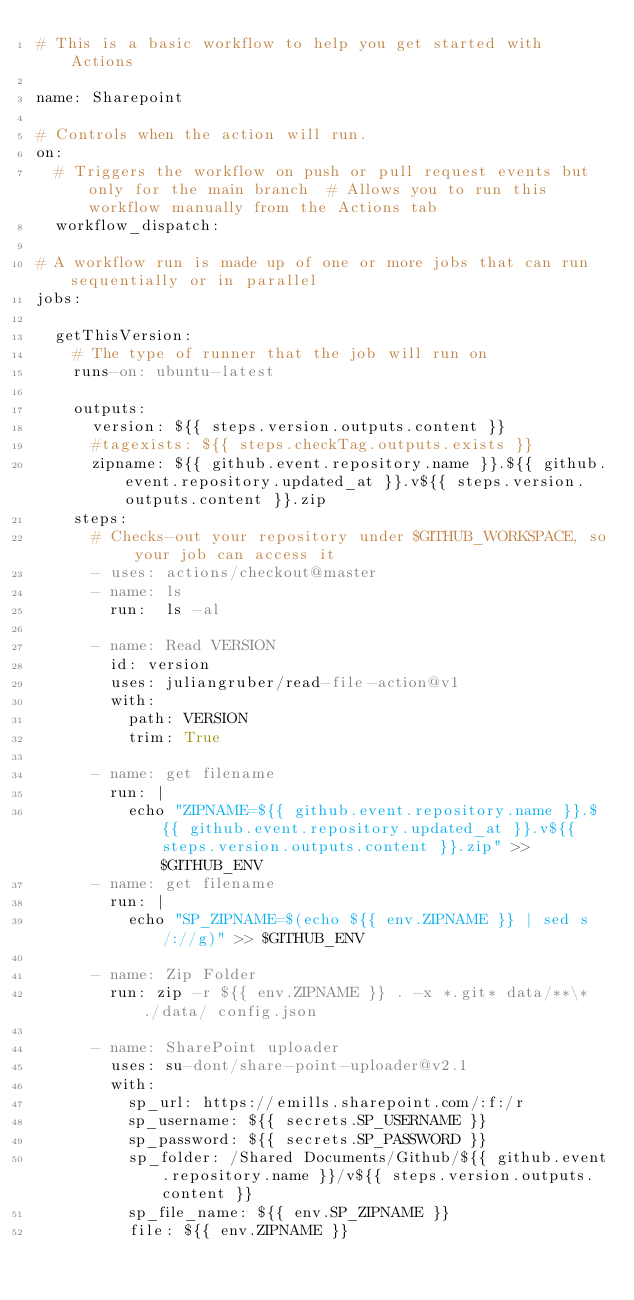<code> <loc_0><loc_0><loc_500><loc_500><_YAML_># This is a basic workflow to help you get started with Actions

name: Sharepoint

# Controls when the action will run. 
on:
  # Triggers the workflow on push or pull request events but only for the main branch  # Allows you to run this workflow manually from the Actions tab
  workflow_dispatch:

# A workflow run is made up of one or more jobs that can run sequentially or in parallel
jobs:
  
  getThisVersion:
    # The type of runner that the job will run on
    runs-on: ubuntu-latest

    outputs:
      version: ${{ steps.version.outputs.content }}
      #tagexists: ${{ steps.checkTag.outputs.exists }}
      zipname: ${{ github.event.repository.name }}.${{ github.event.repository.updated_at }}.v${{ steps.version.outputs.content }}.zip
    steps:
      # Checks-out your repository under $GITHUB_WORKSPACE, so your job can access it
      - uses: actions/checkout@master
      - name: ls
        run:  ls -al
          
      - name: Read VERSION
        id: version
        uses: juliangruber/read-file-action@v1
        with:
          path: VERSION
          trim: True

      - name: get filename
        run: |
          echo "ZIPNAME=${{ github.event.repository.name }}.${{ github.event.repository.updated_at }}.v${{ steps.version.outputs.content }}.zip" >> $GITHUB_ENV
      - name: get filename
        run: |
          echo "SP_ZIPNAME=$(echo ${{ env.ZIPNAME }} | sed s/://g)" >> $GITHUB_ENV
        
      - name: Zip Folder
        run: zip -r ${{ env.ZIPNAME }} . -x *.git* data/**\* ./data/ config.json        
        
      - name: SharePoint uploader
        uses: su-dont/share-point-uploader@v2.1
        with:
          sp_url: https://emills.sharepoint.com/:f:/r
          sp_username: ${{ secrets.SP_USERNAME }}
          sp_password: ${{ secrets.SP_PASSWORD }}
          sp_folder: /Shared Documents/Github/${{ github.event.repository.name }}/v${{ steps.version.outputs.content }}
          sp_file_name: ${{ env.SP_ZIPNAME }}
          file: ${{ env.ZIPNAME }}
</code> 